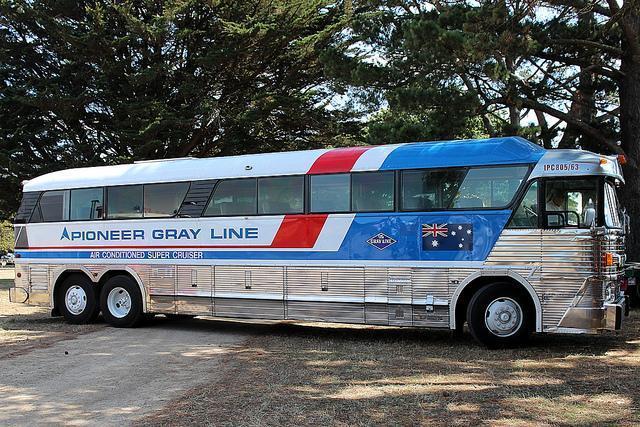How many buses are visible?
Give a very brief answer. 1. 